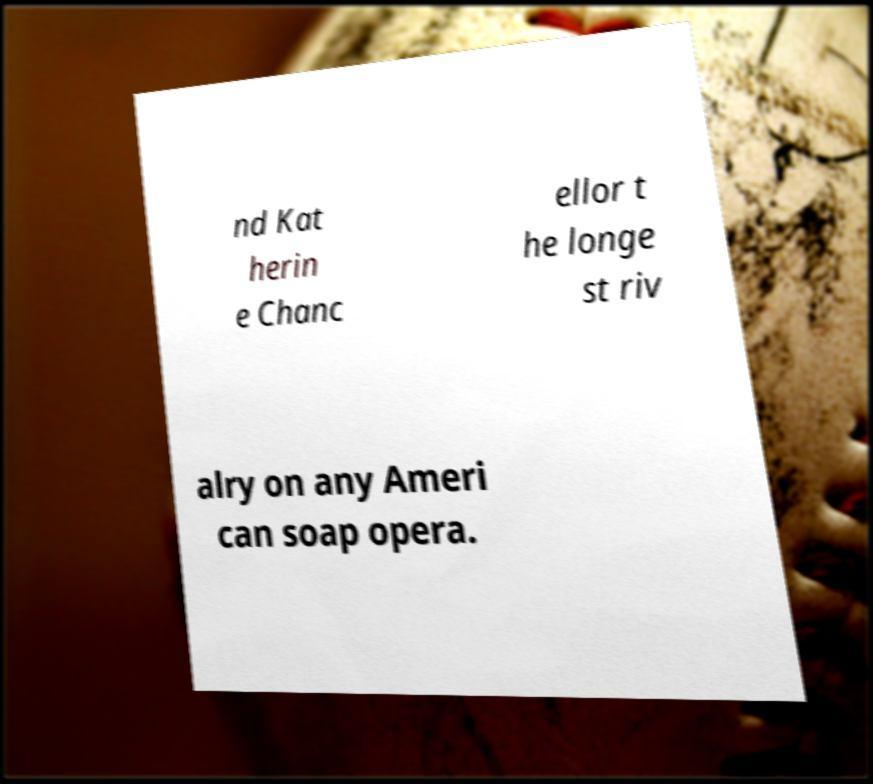Could you assist in decoding the text presented in this image and type it out clearly? nd Kat herin e Chanc ellor t he longe st riv alry on any Ameri can soap opera. 